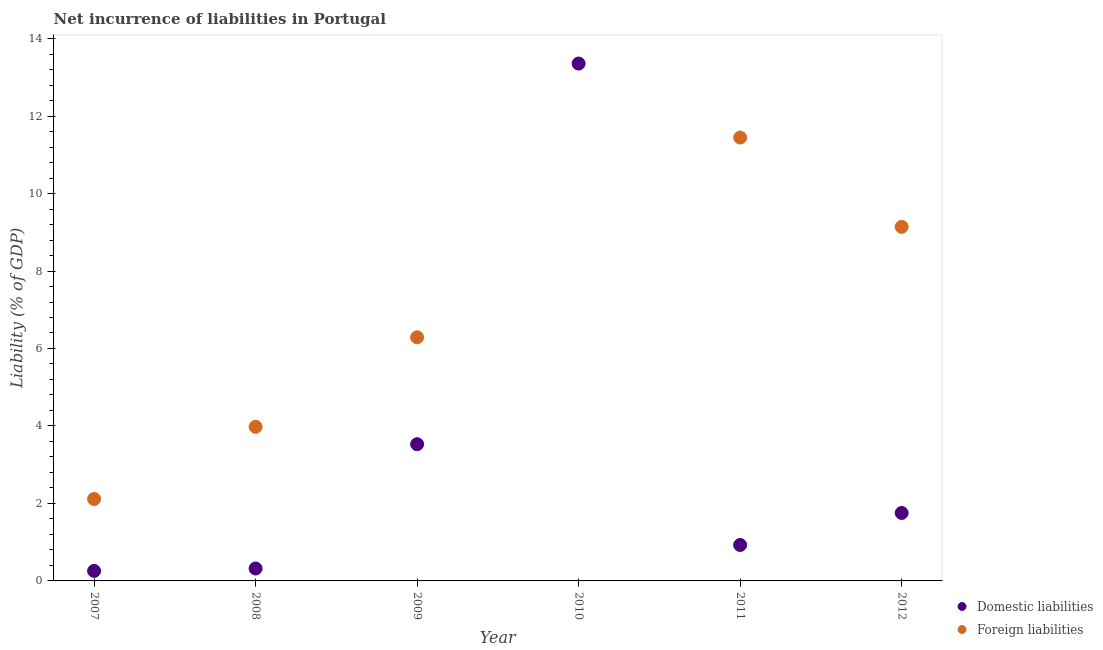Is the number of dotlines equal to the number of legend labels?
Provide a short and direct response. No. What is the incurrence of foreign liabilities in 2011?
Keep it short and to the point. 11.45. Across all years, what is the maximum incurrence of foreign liabilities?
Make the answer very short. 11.45. Across all years, what is the minimum incurrence of foreign liabilities?
Offer a very short reply. 0. What is the total incurrence of domestic liabilities in the graph?
Offer a terse response. 20.15. What is the difference between the incurrence of domestic liabilities in 2007 and that in 2009?
Keep it short and to the point. -3.27. What is the difference between the incurrence of foreign liabilities in 2011 and the incurrence of domestic liabilities in 2008?
Make the answer very short. 11.12. What is the average incurrence of foreign liabilities per year?
Ensure brevity in your answer.  5.49. In the year 2012, what is the difference between the incurrence of domestic liabilities and incurrence of foreign liabilities?
Your answer should be compact. -7.39. What is the ratio of the incurrence of foreign liabilities in 2008 to that in 2012?
Your answer should be very brief. 0.44. Is the difference between the incurrence of foreign liabilities in 2008 and 2009 greater than the difference between the incurrence of domestic liabilities in 2008 and 2009?
Make the answer very short. Yes. What is the difference between the highest and the second highest incurrence of domestic liabilities?
Ensure brevity in your answer.  9.83. What is the difference between the highest and the lowest incurrence of foreign liabilities?
Your answer should be very brief. 11.45. Is the incurrence of domestic liabilities strictly greater than the incurrence of foreign liabilities over the years?
Provide a short and direct response. No. Is the incurrence of foreign liabilities strictly less than the incurrence of domestic liabilities over the years?
Your answer should be compact. No. How many dotlines are there?
Provide a short and direct response. 2. How many years are there in the graph?
Offer a very short reply. 6. What is the difference between two consecutive major ticks on the Y-axis?
Provide a succinct answer. 2. Does the graph contain any zero values?
Offer a terse response. Yes. Does the graph contain grids?
Your answer should be very brief. No. How are the legend labels stacked?
Your answer should be very brief. Vertical. What is the title of the graph?
Keep it short and to the point. Net incurrence of liabilities in Portugal. Does "Commercial service exports" appear as one of the legend labels in the graph?
Make the answer very short. No. What is the label or title of the Y-axis?
Give a very brief answer. Liability (% of GDP). What is the Liability (% of GDP) in Domestic liabilities in 2007?
Your answer should be compact. 0.26. What is the Liability (% of GDP) of Foreign liabilities in 2007?
Your answer should be compact. 2.11. What is the Liability (% of GDP) of Domestic liabilities in 2008?
Provide a short and direct response. 0.32. What is the Liability (% of GDP) of Foreign liabilities in 2008?
Provide a short and direct response. 3.98. What is the Liability (% of GDP) in Domestic liabilities in 2009?
Offer a terse response. 3.53. What is the Liability (% of GDP) of Foreign liabilities in 2009?
Your response must be concise. 6.29. What is the Liability (% of GDP) in Domestic liabilities in 2010?
Offer a very short reply. 13.36. What is the Liability (% of GDP) of Foreign liabilities in 2010?
Make the answer very short. 0. What is the Liability (% of GDP) in Domestic liabilities in 2011?
Provide a short and direct response. 0.93. What is the Liability (% of GDP) of Foreign liabilities in 2011?
Make the answer very short. 11.45. What is the Liability (% of GDP) of Domestic liabilities in 2012?
Ensure brevity in your answer.  1.75. What is the Liability (% of GDP) of Foreign liabilities in 2012?
Make the answer very short. 9.14. Across all years, what is the maximum Liability (% of GDP) of Domestic liabilities?
Offer a very short reply. 13.36. Across all years, what is the maximum Liability (% of GDP) of Foreign liabilities?
Provide a short and direct response. 11.45. Across all years, what is the minimum Liability (% of GDP) in Domestic liabilities?
Your answer should be compact. 0.26. Across all years, what is the minimum Liability (% of GDP) of Foreign liabilities?
Your response must be concise. 0. What is the total Liability (% of GDP) of Domestic liabilities in the graph?
Keep it short and to the point. 20.15. What is the total Liability (% of GDP) of Foreign liabilities in the graph?
Provide a short and direct response. 32.97. What is the difference between the Liability (% of GDP) in Domestic liabilities in 2007 and that in 2008?
Your answer should be very brief. -0.06. What is the difference between the Liability (% of GDP) of Foreign liabilities in 2007 and that in 2008?
Make the answer very short. -1.86. What is the difference between the Liability (% of GDP) in Domestic liabilities in 2007 and that in 2009?
Your response must be concise. -3.27. What is the difference between the Liability (% of GDP) in Foreign liabilities in 2007 and that in 2009?
Make the answer very short. -4.17. What is the difference between the Liability (% of GDP) in Domestic liabilities in 2007 and that in 2010?
Keep it short and to the point. -13.1. What is the difference between the Liability (% of GDP) of Domestic liabilities in 2007 and that in 2011?
Provide a short and direct response. -0.67. What is the difference between the Liability (% of GDP) in Foreign liabilities in 2007 and that in 2011?
Your answer should be very brief. -9.33. What is the difference between the Liability (% of GDP) in Domestic liabilities in 2007 and that in 2012?
Your answer should be compact. -1.5. What is the difference between the Liability (% of GDP) in Foreign liabilities in 2007 and that in 2012?
Ensure brevity in your answer.  -7.02. What is the difference between the Liability (% of GDP) of Domestic liabilities in 2008 and that in 2009?
Your answer should be compact. -3.21. What is the difference between the Liability (% of GDP) in Foreign liabilities in 2008 and that in 2009?
Keep it short and to the point. -2.31. What is the difference between the Liability (% of GDP) of Domestic liabilities in 2008 and that in 2010?
Make the answer very short. -13.03. What is the difference between the Liability (% of GDP) of Domestic liabilities in 2008 and that in 2011?
Your response must be concise. -0.61. What is the difference between the Liability (% of GDP) in Foreign liabilities in 2008 and that in 2011?
Your response must be concise. -7.47. What is the difference between the Liability (% of GDP) of Domestic liabilities in 2008 and that in 2012?
Keep it short and to the point. -1.43. What is the difference between the Liability (% of GDP) in Foreign liabilities in 2008 and that in 2012?
Offer a terse response. -5.16. What is the difference between the Liability (% of GDP) of Domestic liabilities in 2009 and that in 2010?
Your answer should be compact. -9.83. What is the difference between the Liability (% of GDP) of Domestic liabilities in 2009 and that in 2011?
Your response must be concise. 2.6. What is the difference between the Liability (% of GDP) in Foreign liabilities in 2009 and that in 2011?
Keep it short and to the point. -5.16. What is the difference between the Liability (% of GDP) in Domestic liabilities in 2009 and that in 2012?
Your response must be concise. 1.78. What is the difference between the Liability (% of GDP) in Foreign liabilities in 2009 and that in 2012?
Give a very brief answer. -2.85. What is the difference between the Liability (% of GDP) in Domestic liabilities in 2010 and that in 2011?
Offer a very short reply. 12.43. What is the difference between the Liability (% of GDP) in Domestic liabilities in 2010 and that in 2012?
Provide a short and direct response. 11.6. What is the difference between the Liability (% of GDP) of Domestic liabilities in 2011 and that in 2012?
Give a very brief answer. -0.83. What is the difference between the Liability (% of GDP) of Foreign liabilities in 2011 and that in 2012?
Provide a short and direct response. 2.31. What is the difference between the Liability (% of GDP) of Domestic liabilities in 2007 and the Liability (% of GDP) of Foreign liabilities in 2008?
Offer a very short reply. -3.72. What is the difference between the Liability (% of GDP) of Domestic liabilities in 2007 and the Liability (% of GDP) of Foreign liabilities in 2009?
Your answer should be very brief. -6.03. What is the difference between the Liability (% of GDP) in Domestic liabilities in 2007 and the Liability (% of GDP) in Foreign liabilities in 2011?
Your response must be concise. -11.19. What is the difference between the Liability (% of GDP) of Domestic liabilities in 2007 and the Liability (% of GDP) of Foreign liabilities in 2012?
Offer a terse response. -8.88. What is the difference between the Liability (% of GDP) of Domestic liabilities in 2008 and the Liability (% of GDP) of Foreign liabilities in 2009?
Give a very brief answer. -5.97. What is the difference between the Liability (% of GDP) in Domestic liabilities in 2008 and the Liability (% of GDP) in Foreign liabilities in 2011?
Offer a very short reply. -11.12. What is the difference between the Liability (% of GDP) of Domestic liabilities in 2008 and the Liability (% of GDP) of Foreign liabilities in 2012?
Offer a very short reply. -8.82. What is the difference between the Liability (% of GDP) in Domestic liabilities in 2009 and the Liability (% of GDP) in Foreign liabilities in 2011?
Your answer should be very brief. -7.92. What is the difference between the Liability (% of GDP) in Domestic liabilities in 2009 and the Liability (% of GDP) in Foreign liabilities in 2012?
Offer a terse response. -5.61. What is the difference between the Liability (% of GDP) in Domestic liabilities in 2010 and the Liability (% of GDP) in Foreign liabilities in 2011?
Your answer should be very brief. 1.91. What is the difference between the Liability (% of GDP) in Domestic liabilities in 2010 and the Liability (% of GDP) in Foreign liabilities in 2012?
Offer a very short reply. 4.22. What is the difference between the Liability (% of GDP) in Domestic liabilities in 2011 and the Liability (% of GDP) in Foreign liabilities in 2012?
Provide a succinct answer. -8.21. What is the average Liability (% of GDP) in Domestic liabilities per year?
Give a very brief answer. 3.36. What is the average Liability (% of GDP) in Foreign liabilities per year?
Provide a short and direct response. 5.49. In the year 2007, what is the difference between the Liability (% of GDP) of Domestic liabilities and Liability (% of GDP) of Foreign liabilities?
Ensure brevity in your answer.  -1.86. In the year 2008, what is the difference between the Liability (% of GDP) in Domestic liabilities and Liability (% of GDP) in Foreign liabilities?
Provide a short and direct response. -3.66. In the year 2009, what is the difference between the Liability (% of GDP) in Domestic liabilities and Liability (% of GDP) in Foreign liabilities?
Ensure brevity in your answer.  -2.76. In the year 2011, what is the difference between the Liability (% of GDP) of Domestic liabilities and Liability (% of GDP) of Foreign liabilities?
Your response must be concise. -10.52. In the year 2012, what is the difference between the Liability (% of GDP) in Domestic liabilities and Liability (% of GDP) in Foreign liabilities?
Your answer should be compact. -7.39. What is the ratio of the Liability (% of GDP) in Domestic liabilities in 2007 to that in 2008?
Offer a terse response. 0.81. What is the ratio of the Liability (% of GDP) of Foreign liabilities in 2007 to that in 2008?
Keep it short and to the point. 0.53. What is the ratio of the Liability (% of GDP) of Domestic liabilities in 2007 to that in 2009?
Ensure brevity in your answer.  0.07. What is the ratio of the Liability (% of GDP) in Foreign liabilities in 2007 to that in 2009?
Your response must be concise. 0.34. What is the ratio of the Liability (% of GDP) in Domestic liabilities in 2007 to that in 2010?
Make the answer very short. 0.02. What is the ratio of the Liability (% of GDP) in Domestic liabilities in 2007 to that in 2011?
Provide a short and direct response. 0.28. What is the ratio of the Liability (% of GDP) in Foreign liabilities in 2007 to that in 2011?
Offer a very short reply. 0.18. What is the ratio of the Liability (% of GDP) in Domestic liabilities in 2007 to that in 2012?
Make the answer very short. 0.15. What is the ratio of the Liability (% of GDP) in Foreign liabilities in 2007 to that in 2012?
Your answer should be very brief. 0.23. What is the ratio of the Liability (% of GDP) in Domestic liabilities in 2008 to that in 2009?
Keep it short and to the point. 0.09. What is the ratio of the Liability (% of GDP) of Foreign liabilities in 2008 to that in 2009?
Your answer should be very brief. 0.63. What is the ratio of the Liability (% of GDP) in Domestic liabilities in 2008 to that in 2010?
Your answer should be very brief. 0.02. What is the ratio of the Liability (% of GDP) of Domestic liabilities in 2008 to that in 2011?
Your answer should be very brief. 0.35. What is the ratio of the Liability (% of GDP) in Foreign liabilities in 2008 to that in 2011?
Your response must be concise. 0.35. What is the ratio of the Liability (% of GDP) of Domestic liabilities in 2008 to that in 2012?
Your response must be concise. 0.18. What is the ratio of the Liability (% of GDP) in Foreign liabilities in 2008 to that in 2012?
Your answer should be compact. 0.44. What is the ratio of the Liability (% of GDP) of Domestic liabilities in 2009 to that in 2010?
Provide a short and direct response. 0.26. What is the ratio of the Liability (% of GDP) of Domestic liabilities in 2009 to that in 2011?
Keep it short and to the point. 3.8. What is the ratio of the Liability (% of GDP) in Foreign liabilities in 2009 to that in 2011?
Keep it short and to the point. 0.55. What is the ratio of the Liability (% of GDP) in Domestic liabilities in 2009 to that in 2012?
Make the answer very short. 2.01. What is the ratio of the Liability (% of GDP) in Foreign liabilities in 2009 to that in 2012?
Make the answer very short. 0.69. What is the ratio of the Liability (% of GDP) of Domestic liabilities in 2010 to that in 2011?
Keep it short and to the point. 14.39. What is the ratio of the Liability (% of GDP) in Domestic liabilities in 2010 to that in 2012?
Offer a very short reply. 7.61. What is the ratio of the Liability (% of GDP) of Domestic liabilities in 2011 to that in 2012?
Keep it short and to the point. 0.53. What is the ratio of the Liability (% of GDP) in Foreign liabilities in 2011 to that in 2012?
Give a very brief answer. 1.25. What is the difference between the highest and the second highest Liability (% of GDP) in Domestic liabilities?
Provide a short and direct response. 9.83. What is the difference between the highest and the second highest Liability (% of GDP) of Foreign liabilities?
Keep it short and to the point. 2.31. What is the difference between the highest and the lowest Liability (% of GDP) in Domestic liabilities?
Ensure brevity in your answer.  13.1. What is the difference between the highest and the lowest Liability (% of GDP) of Foreign liabilities?
Give a very brief answer. 11.45. 